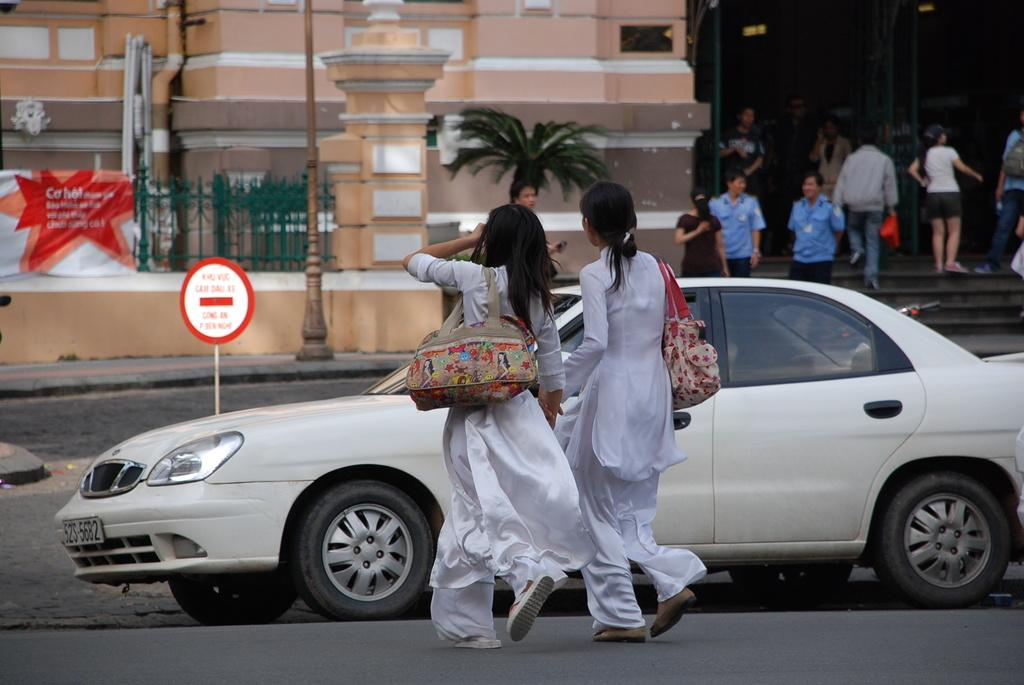What can be seen in the image that people use for carrying items? There are bags in the image that people use for carrying items. What mode of transportation is visible in the image? There is a car in the image. What type of signage is present in the image? There is a signboard in the image. What kind of promotional material is visible in the image? There is a banner in the image. What type of barrier is present in the image? There is a fence in the image. What vertical structure is present in the image? There is a pole in the image. What type of man-made structure is visible in the image? There is a building in the image. What architectural feature is present in the image? There are steps in the image. What type of plant is visible in the image? There is a tree in the image. What activity are two people engaged in within the image? Two women are walking on the road in the image. What is the general position of some people in the image? Some people are standing in the image. What additional unspecified objects are present in the image? There are some unspecified objects in the image. What type of pen can be seen in the image? There is no pen present in the image. What type of face can be seen on the building in the image? There is no face depicted on the building in the image. 